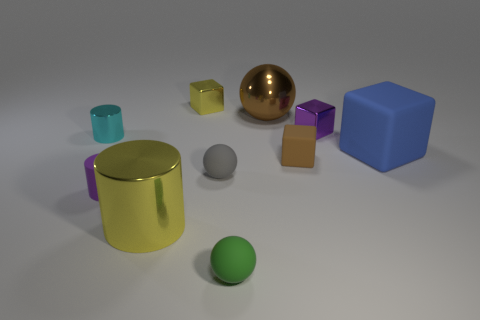Subtract 1 cubes. How many cubes are left? 3 Subtract all cylinders. How many objects are left? 7 Subtract 1 gray spheres. How many objects are left? 9 Subtract all green balls. Subtract all small purple matte objects. How many objects are left? 8 Add 2 tiny cylinders. How many tiny cylinders are left? 4 Add 5 cyan cylinders. How many cyan cylinders exist? 6 